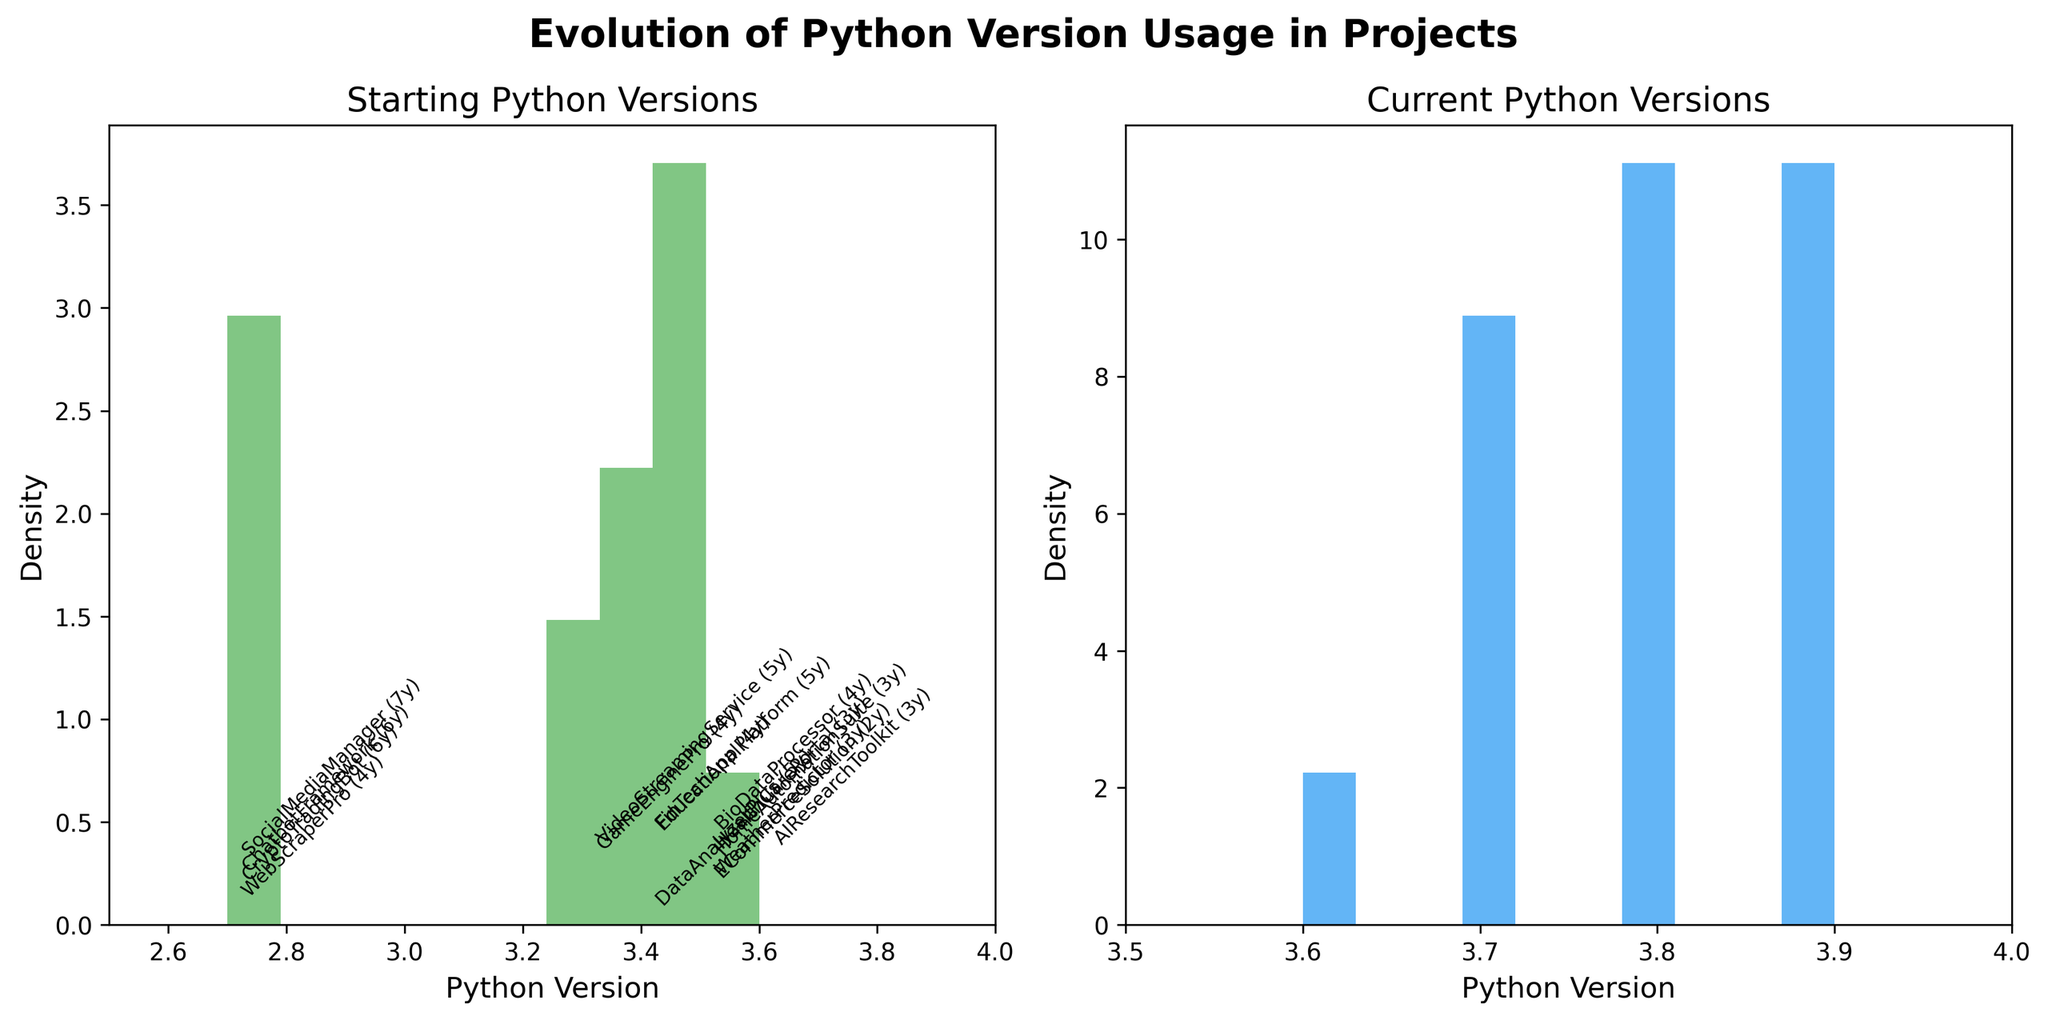What is the title of the figure? The title of the figure is usually displayed at the top of the plot. In this case, it reads "Evolution of Python Version Usage in Projects" in bold font.
Answer: Evolution of Python Version Usage in Projects What are the two subplots about? The titles of the subplots indicate their respective contents. The left subplot is titled "Starting Python Versions," and the right subplot is titled "Current Python Versions."
Answer: Starting Python Versions and Current Python Versions Which subplot shows the density of Python versions starting from earlier ones like 2.7? By examining the titles and data distribution, the left subplot titled "Starting Python Versions" shows the density of Python versions starting in earlier versions like 2.7.
Answer: Starting Python Versions How many bins are used in the histograms of both subplots? The histograms in both subplots have 10 bins each, as indicated by the "bins=10" parameter in the code.
Answer: 10 Which Python version appears to have the highest density in the starting versions subplot? By visual inspection of the left subplot, the most concentrated data range appears to be around Python version 3.5.
Answer: 3.5 Which subplots contain the Python version 3.9? Python version 3.9 is shown in both the left subplot "Starting Python Versions" and the right subplot "Current Python Versions," but it is more prominent in the current versions subplot.
Answer: Both How does the density of Python version 2.7 in the 'Starting Python Versions' subplot compare with any versions in the 'Current Python Versions' subplot? Python version 2.7 shows a lower density in the starting versions subplot, and it is absent in the current versions subplot, indicating a move away from 2.7 in current use.
Answer: Lower and absent in current Which project is annotated in the 'Starting Python Versions' subplot to have the longest lifespan? The annotation includes both the project name and lifespan in years; "SocialMediaManager" shows a lifespan of 7 years, the longest period among the projects.
Answer: SocialMediaManager What is the x-axis range of both subplots? The x-axis range is evident from the axis limits set in the code. The starting versions subplot ranges from 2.5 to 4.0, and the current versions subplot ranges from 3.5 to 4.0.
Answer: 2.5 to 4.0 and 3.5 to 4.0 What does the color difference in the histograms imply in the subplots? The left subplot uses a greenish color, and the right subplot uses a blueish color to differentiate between the density plots of starting and current Python versions clearly.
Answer: Different datasets 